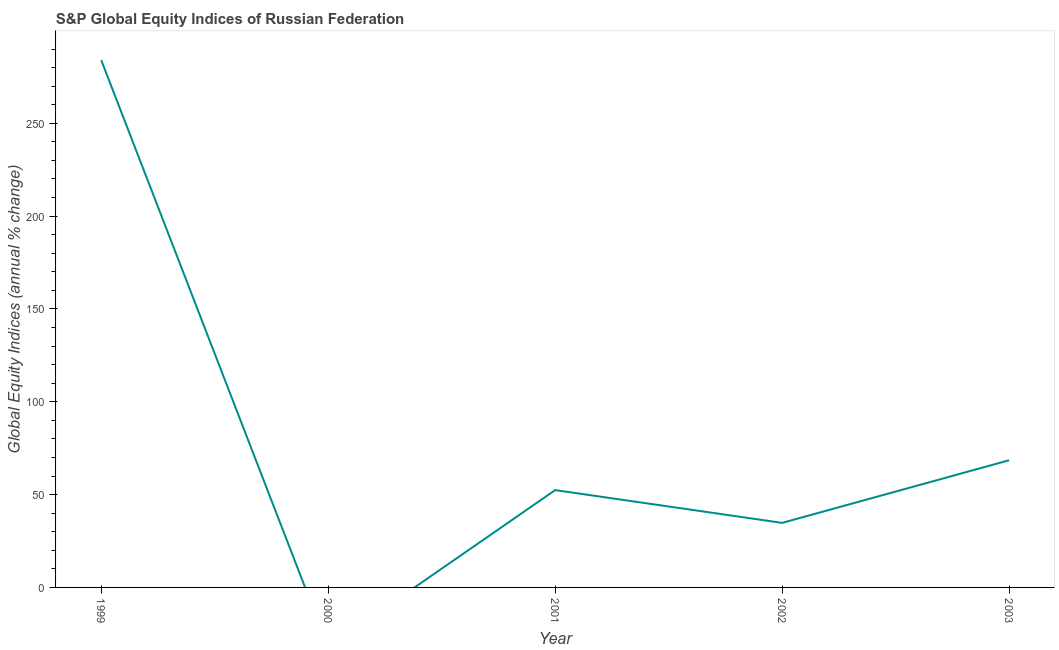What is the s&p global equity indices in 2002?
Keep it short and to the point. 34.77. Across all years, what is the maximum s&p global equity indices?
Offer a very short reply. 284. What is the sum of the s&p global equity indices?
Offer a terse response. 439.69. What is the difference between the s&p global equity indices in 1999 and 2002?
Make the answer very short. 249.23. What is the average s&p global equity indices per year?
Keep it short and to the point. 87.94. What is the median s&p global equity indices?
Your answer should be compact. 52.42. What is the ratio of the s&p global equity indices in 2001 to that in 2002?
Give a very brief answer. 1.51. Is the difference between the s&p global equity indices in 2001 and 2002 greater than the difference between any two years?
Your response must be concise. No. What is the difference between the highest and the second highest s&p global equity indices?
Provide a short and direct response. 215.5. What is the difference between the highest and the lowest s&p global equity indices?
Your response must be concise. 284. In how many years, is the s&p global equity indices greater than the average s&p global equity indices taken over all years?
Provide a short and direct response. 1. Does the s&p global equity indices monotonically increase over the years?
Give a very brief answer. No. How many lines are there?
Ensure brevity in your answer.  1. How many years are there in the graph?
Ensure brevity in your answer.  5. What is the difference between two consecutive major ticks on the Y-axis?
Provide a succinct answer. 50. Are the values on the major ticks of Y-axis written in scientific E-notation?
Offer a terse response. No. Does the graph contain any zero values?
Give a very brief answer. Yes. What is the title of the graph?
Make the answer very short. S&P Global Equity Indices of Russian Federation. What is the label or title of the Y-axis?
Your response must be concise. Global Equity Indices (annual % change). What is the Global Equity Indices (annual % change) in 1999?
Ensure brevity in your answer.  284. What is the Global Equity Indices (annual % change) of 2000?
Your answer should be very brief. 0. What is the Global Equity Indices (annual % change) in 2001?
Provide a short and direct response. 52.42. What is the Global Equity Indices (annual % change) in 2002?
Make the answer very short. 34.77. What is the Global Equity Indices (annual % change) in 2003?
Your response must be concise. 68.5. What is the difference between the Global Equity Indices (annual % change) in 1999 and 2001?
Your response must be concise. 231.58. What is the difference between the Global Equity Indices (annual % change) in 1999 and 2002?
Provide a succinct answer. 249.23. What is the difference between the Global Equity Indices (annual % change) in 1999 and 2003?
Offer a terse response. 215.5. What is the difference between the Global Equity Indices (annual % change) in 2001 and 2002?
Make the answer very short. 17.65. What is the difference between the Global Equity Indices (annual % change) in 2001 and 2003?
Provide a succinct answer. -16.08. What is the difference between the Global Equity Indices (annual % change) in 2002 and 2003?
Provide a succinct answer. -33.73. What is the ratio of the Global Equity Indices (annual % change) in 1999 to that in 2001?
Your response must be concise. 5.42. What is the ratio of the Global Equity Indices (annual % change) in 1999 to that in 2002?
Your answer should be very brief. 8.17. What is the ratio of the Global Equity Indices (annual % change) in 1999 to that in 2003?
Your answer should be very brief. 4.15. What is the ratio of the Global Equity Indices (annual % change) in 2001 to that in 2002?
Provide a short and direct response. 1.51. What is the ratio of the Global Equity Indices (annual % change) in 2001 to that in 2003?
Provide a succinct answer. 0.77. What is the ratio of the Global Equity Indices (annual % change) in 2002 to that in 2003?
Your response must be concise. 0.51. 